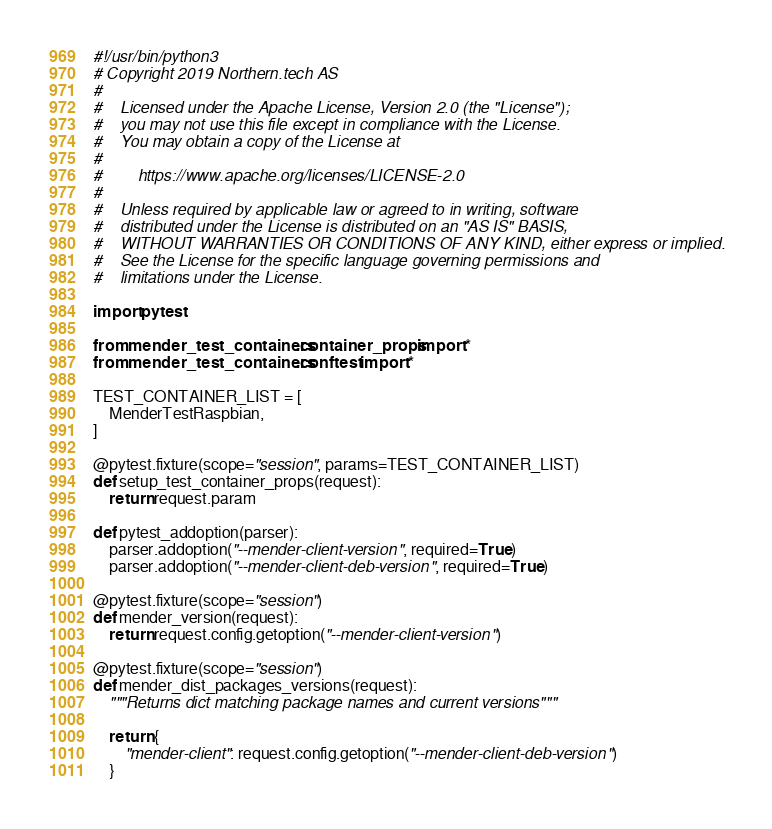<code> <loc_0><loc_0><loc_500><loc_500><_Python_>#!/usr/bin/python3
# Copyright 2019 Northern.tech AS
#
#    Licensed under the Apache License, Version 2.0 (the "License");
#    you may not use this file except in compliance with the License.
#    You may obtain a copy of the License at
#
#        https://www.apache.org/licenses/LICENSE-2.0
#
#    Unless required by applicable law or agreed to in writing, software
#    distributed under the License is distributed on an "AS IS" BASIS,
#    WITHOUT WARRANTIES OR CONDITIONS OF ANY KIND, either express or implied.
#    See the License for the specific language governing permissions and
#    limitations under the License.

import pytest

from mender_test_containers.container_props import *
from mender_test_containers.conftest import *

TEST_CONTAINER_LIST = [
    MenderTestRaspbian,
]

@pytest.fixture(scope="session", params=TEST_CONTAINER_LIST)
def setup_test_container_props(request):
    return request.param

def pytest_addoption(parser):
    parser.addoption("--mender-client-version", required=True)
    parser.addoption("--mender-client-deb-version", required=True)

@pytest.fixture(scope="session")
def mender_version(request):
    return request.config.getoption("--mender-client-version")

@pytest.fixture(scope="session")
def mender_dist_packages_versions(request):
    """Returns dict matching package names and current versions"""

    return {
        "mender-client": request.config.getoption("--mender-client-deb-version")
    }
</code> 